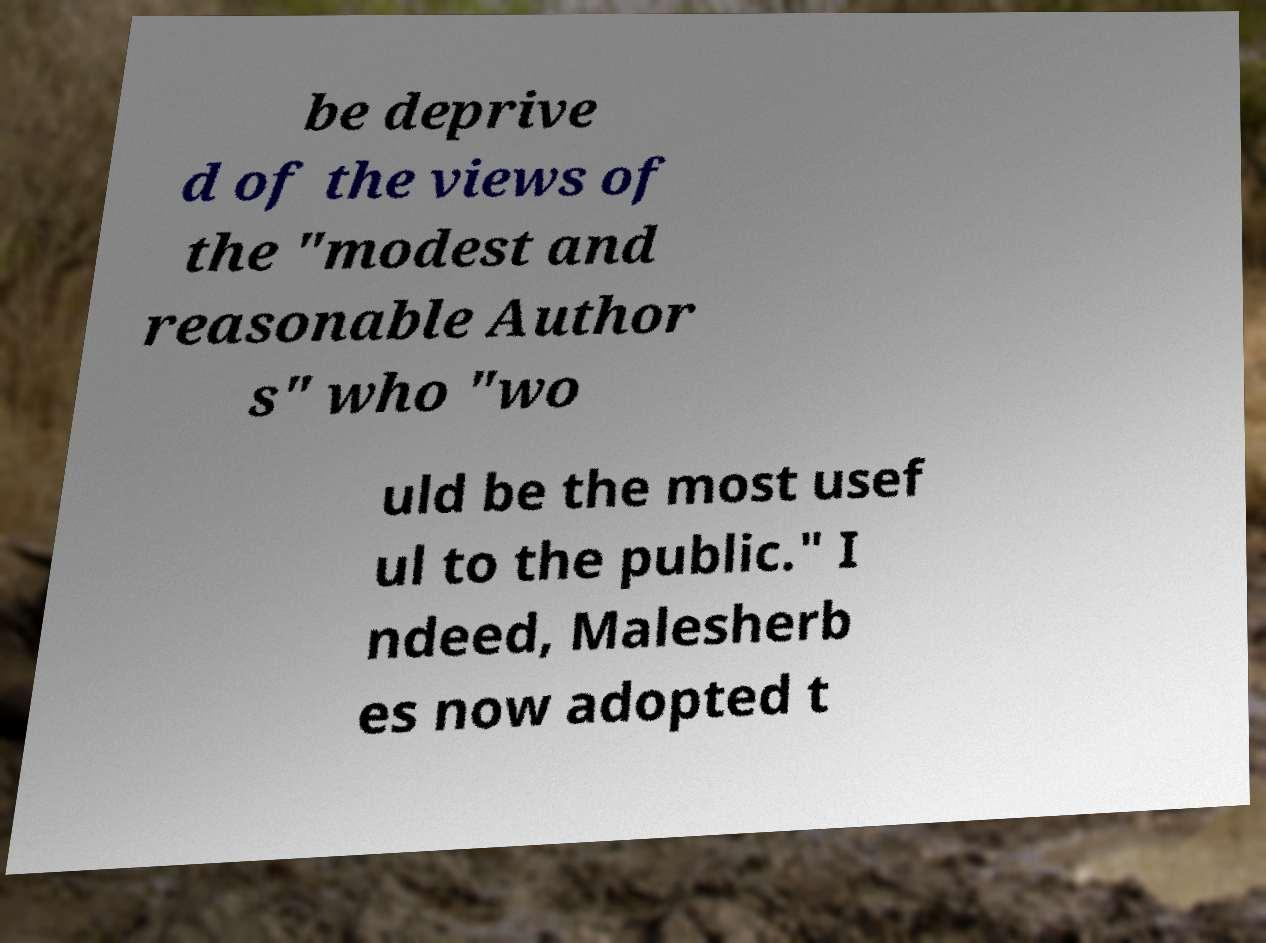What messages or text are displayed in this image? I need them in a readable, typed format. be deprive d of the views of the "modest and reasonable Author s" who "wo uld be the most usef ul to the public." I ndeed, Malesherb es now adopted t 